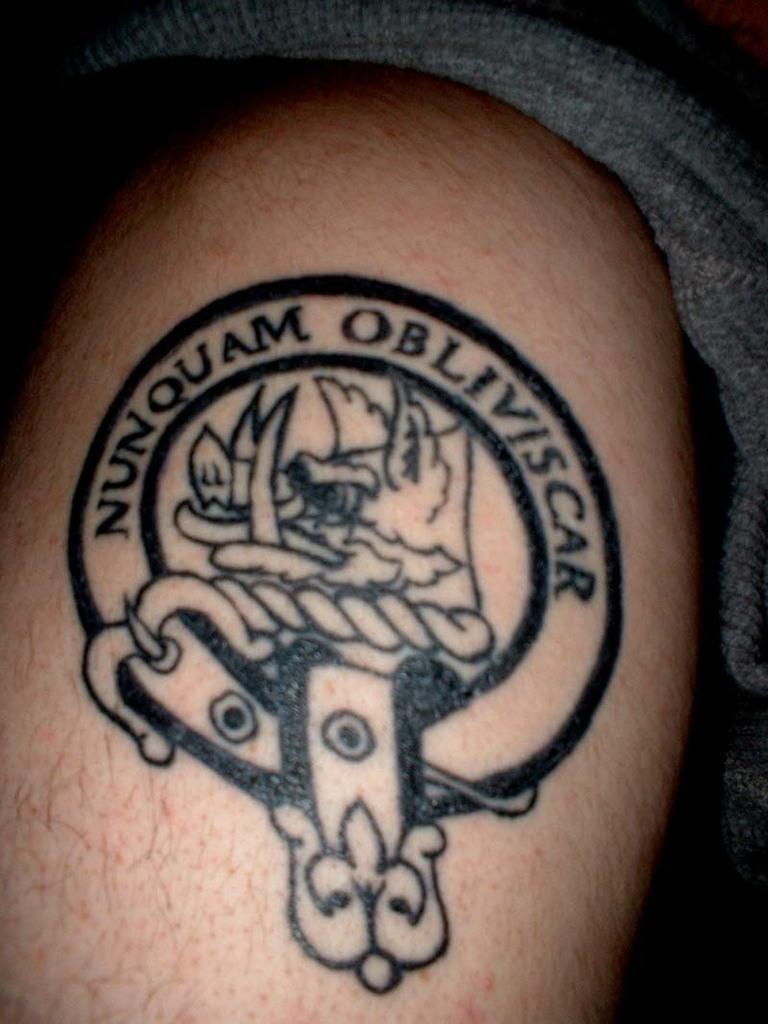Please provide a concise description of this image. In the image we can see the human body and we can see the tattoo on the body. Here we can see the cloth and the background is dark. 